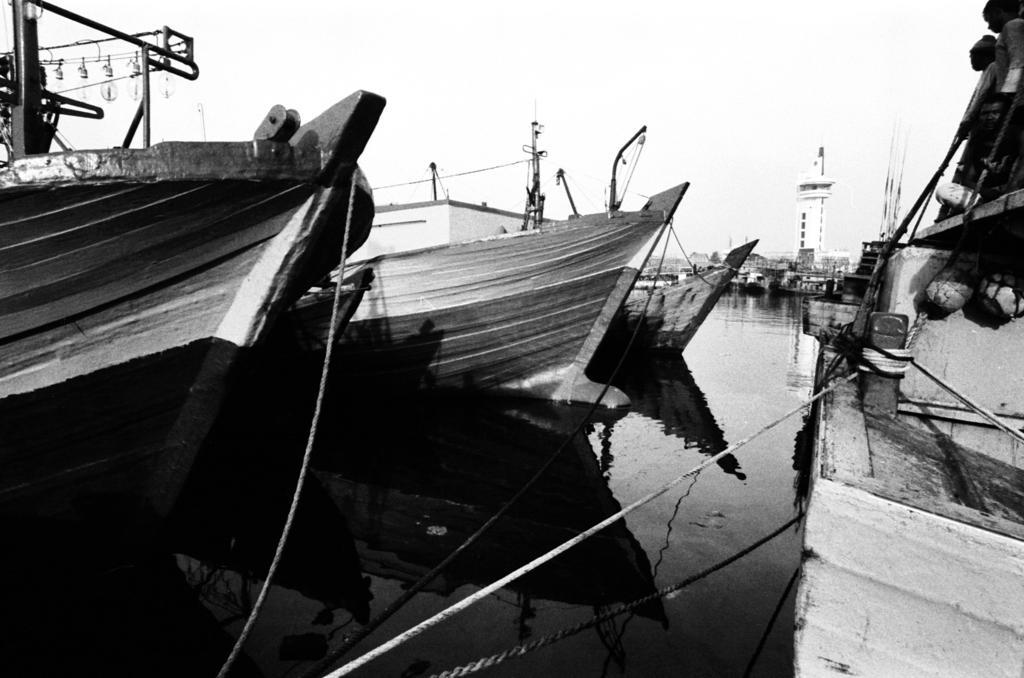How would you summarize this image in a sentence or two? This is a black and white picture where we can see boats are floating on the water. Here we can see the ropes tied to the stones and in the background, we can see the building and the sky. 